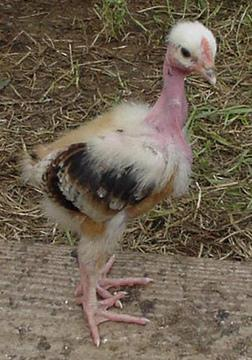Question: why does the bird have few feathers?
Choices:
A. It is young.
B. It is shedding.
C. It is old.
D. It hasn't grown them yet.
Answer with the letter. Answer: A Question: what color is the grass?
Choices:
A. Brown.
B. Blue.
C. White.
D. Green.
Answer with the letter. Answer: D Question: how many birds in the picture?
Choices:
A. One.
B. Zero.
C. Two.
D. Three.
Answer with the letter. Answer: A Question: what color are the bird's feet?
Choices:
A. Pink.
B. Yellow.
C. Orange.
D. White.
Answer with the letter. Answer: A 